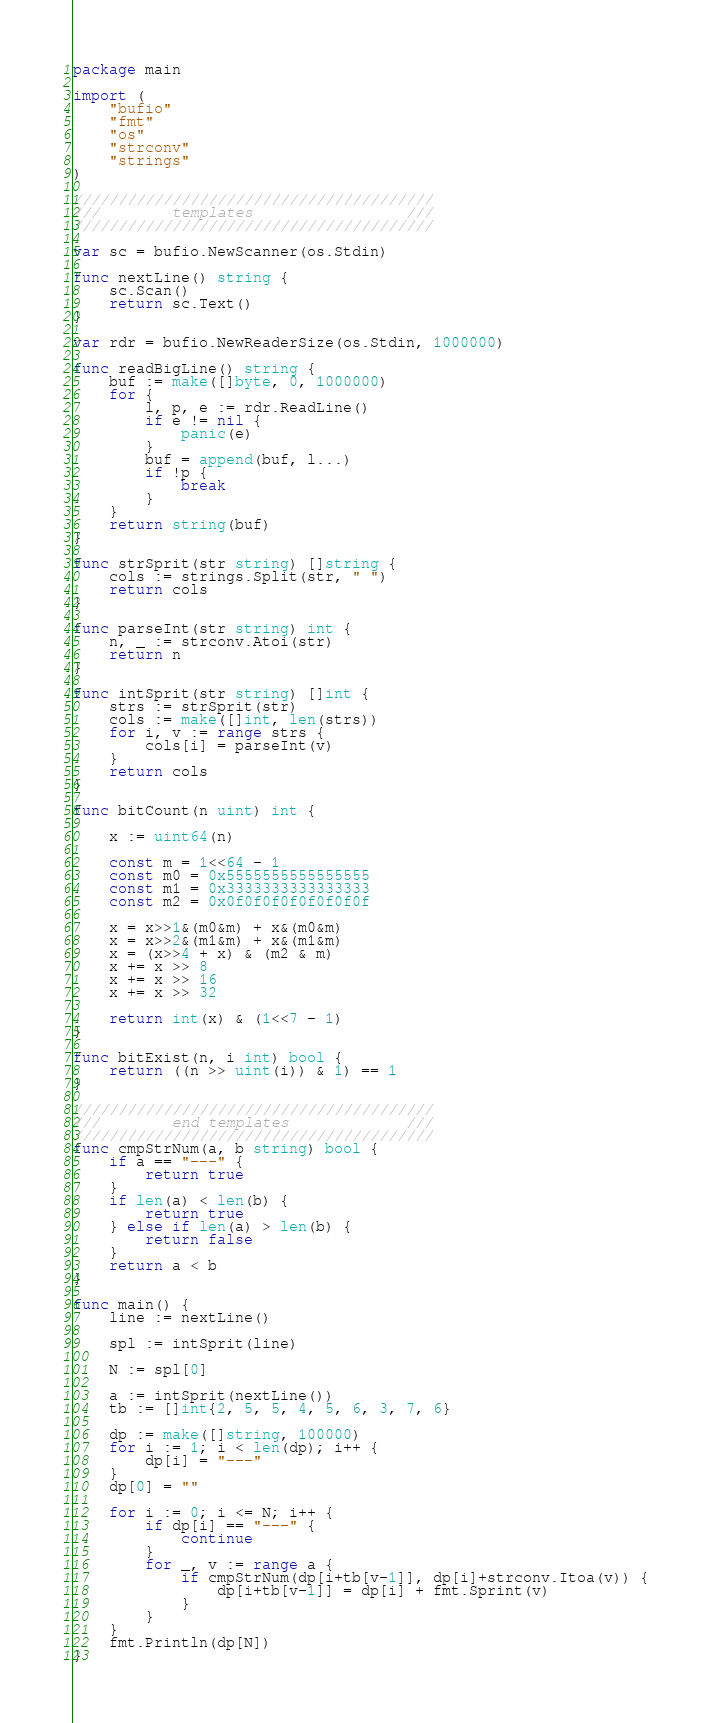<code> <loc_0><loc_0><loc_500><loc_500><_Go_>package main

import (
	"bufio"
	"fmt"
	"os"
	"strconv"
	"strings"
)

////////////////////////////////////////
///        templates                 ///
////////////////////////////////////////

var sc = bufio.NewScanner(os.Stdin)

func nextLine() string {
	sc.Scan()
	return sc.Text()
}

var rdr = bufio.NewReaderSize(os.Stdin, 1000000)

func readBigLine() string {
	buf := make([]byte, 0, 1000000)
	for {
		l, p, e := rdr.ReadLine()
		if e != nil {
			panic(e)
		}
		buf = append(buf, l...)
		if !p {
			break
		}
	}
	return string(buf)
}

func strSprit(str string) []string {
	cols := strings.Split(str, " ")
	return cols
}

func parseInt(str string) int {
	n, _ := strconv.Atoi(str)
	return n
}

func intSprit(str string) []int {
	strs := strSprit(str)
	cols := make([]int, len(strs))
	for i, v := range strs {
		cols[i] = parseInt(v)
	}
	return cols
}

func bitCount(n uint) int {

	x := uint64(n)

	const m = 1<<64 - 1
	const m0 = 0x5555555555555555
	const m1 = 0x3333333333333333
	const m2 = 0x0f0f0f0f0f0f0f0f

	x = x>>1&(m0&m) + x&(m0&m)
	x = x>>2&(m1&m) + x&(m1&m)
	x = (x>>4 + x) & (m2 & m)
	x += x >> 8
	x += x >> 16
	x += x >> 32

	return int(x) & (1<<7 - 1)
}

func bitExist(n, i int) bool {
	return ((n >> uint(i)) & 1) == 1
}

////////////////////////////////////////
///        end templates             ///
////////////////////////////////////////
func cmpStrNum(a, b string) bool {
	if a == "---" {
		return true
	}
	if len(a) < len(b) {
		return true
	} else if len(a) > len(b) {
		return false
	}
	return a < b
}

func main() {
	line := nextLine()

	spl := intSprit(line)

	N := spl[0]

	a := intSprit(nextLine())
	tb := []int{2, 5, 5, 4, 5, 6, 3, 7, 6}

	dp := make([]string, 100000)
	for i := 1; i < len(dp); i++ {
		dp[i] = "---"
	}
	dp[0] = ""

	for i := 0; i <= N; i++ {
		if dp[i] == "---" {
			continue
		}
		for _, v := range a {
			if cmpStrNum(dp[i+tb[v-1]], dp[i]+strconv.Itoa(v)) {
				dp[i+tb[v-1]] = dp[i] + fmt.Sprint(v)
			}
		}
	}
	fmt.Println(dp[N])
}
</code> 